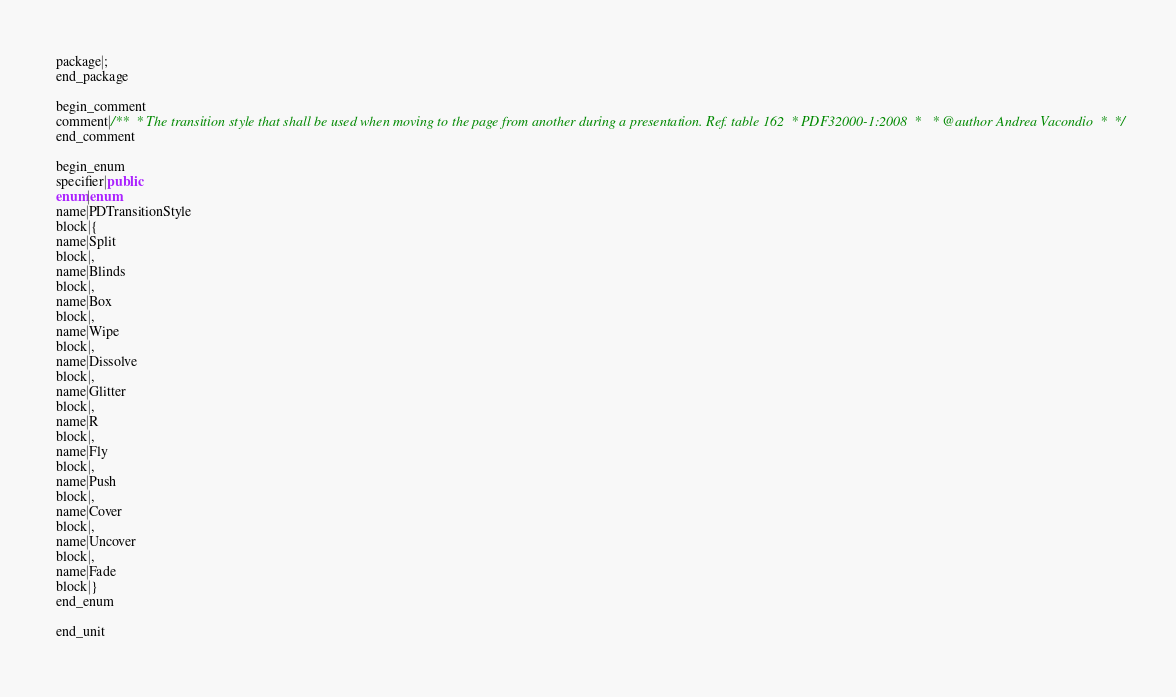Convert code to text. <code><loc_0><loc_0><loc_500><loc_500><_Java_>package|;
end_package

begin_comment
comment|/**  * The transition style that shall be used when moving to the page from another during a presentation. Ref. table 162  * PDF32000-1:2008  *   * @author Andrea Vacondio  *  */
end_comment

begin_enum
specifier|public
enum|enum
name|PDTransitionStyle
block|{
name|Split
block|,
name|Blinds
block|,
name|Box
block|,
name|Wipe
block|,
name|Dissolve
block|,
name|Glitter
block|,
name|R
block|,
name|Fly
block|,
name|Push
block|,
name|Cover
block|,
name|Uncover
block|,
name|Fade
block|}
end_enum

end_unit

</code> 